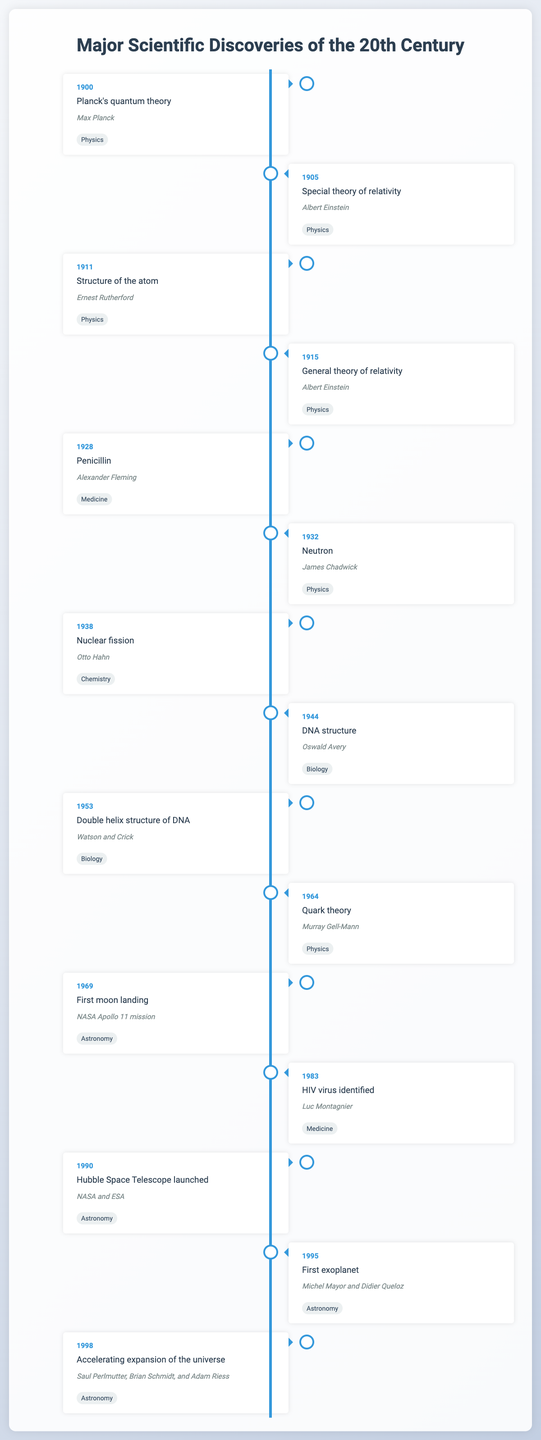What discovery was made in 1905? The table shows that the discovery made in 1905 was the "Special theory of relativity" by Albert Einstein.
Answer: Special theory of relativity Who discovered penicillin? According to the table, penicillin was discovered by Alexander Fleming.
Answer: Alexander Fleming In what year was the structure of the DNA described? The table indicates that the structure of DNA was first described in 1953 by Watson and Crick.
Answer: 1953 How many discoveries are listed in the field of Astronomy? There are four entries in the table related to Astronomy: the First moon landing in 1969, Hubble Space Telescope launched in 1990, First exoplanet in 1995, and Accelerating expansion of the universe in 1998.
Answer: 4 Which scientist made discoveries in both Physics and Medicine? By reviewing the table, we see that there is no single scientist who discovered significant events in both listed fields. The scientists listed belong primarily to one field.
Answer: No What is the time span between the discovery of penicillin and the identification of the HIV virus? Penicillin was discovered in 1928 and the HIV virus was identified in 1983. The time span between the two discoveries is 1983 - 1928 = 55 years.
Answer: 55 years Which year had the most significant discoveries and how many? Examining the table, there are several notable discoveries, but 1953 includes the Double helix structure of DNA. Counting all entries, however, there's not a single year with multiple discoveries exceeding two in this table.
Answer: No year exceeds two discoveries Was the first moon landing before or after 1944? The table shows the first moon landing was in 1969, which is after the year 1944 when the DNA structure was discovered by Oswald Avery.
Answer: After Who are the scientists involved in the discovery of the Accelerating expansion of the universe? The table lists Saul Perlmutter, Brian Schmidt, and Adam Riess as the scientists involved in this discovery made in 1998.
Answer: Saul Perlmutter, Brian Schmidt, and Adam Riess How many discoveries were made in the field of Biology? Upon checking the table, there are two discoveries in Biology: DNA structure in 1944 and the Double helix structure of DNA in 1953.
Answer: 2 What was the primary field of the scientists who discovered the neutron? The table indicates that the neutron was discovered by James Chadwick, who is categorized under Physics.
Answer: Physics 